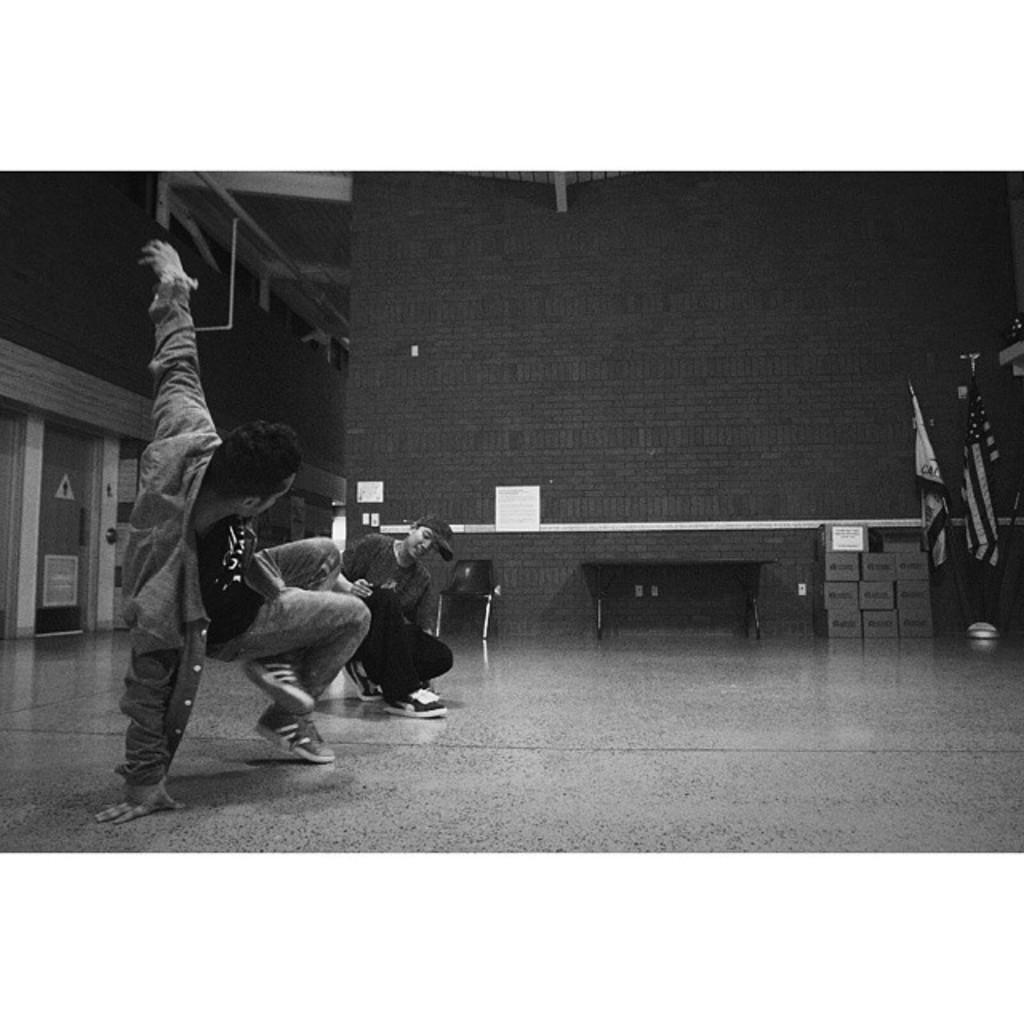How would you summarize this image in a sentence or two? In this picture we can observe two men dancing on the floor. We can observe two flags on the right side. In the background there is a wall. This is a black and white image. 